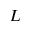Convert formula to latex. <formula><loc_0><loc_0><loc_500><loc_500>L</formula> 